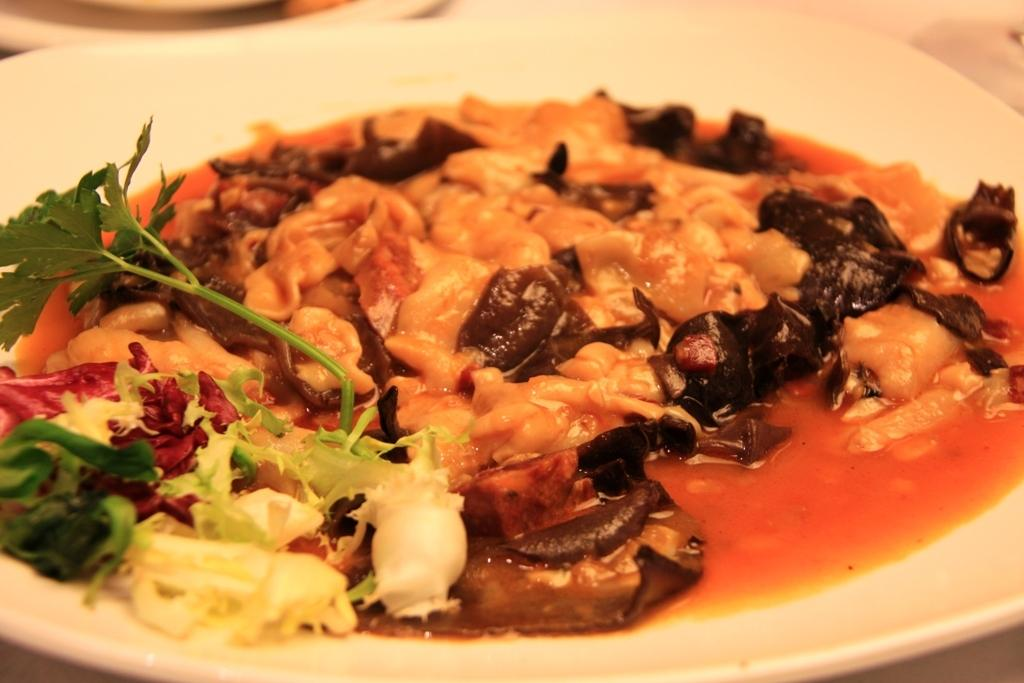What is present on the plate in the image? There is a food item on the plate in the image. What color is the plate? The plate is white in color. Are there any additional elements on the plate besides the food item? Yes, there are leaves on the plate. What type of drink is being served in the image? There is no drink present in the image; it only features a plate with a food item and leaves. How many clams are visible on the plate in the image? There are no clams present in the image; the food item on the plate is not specified. 